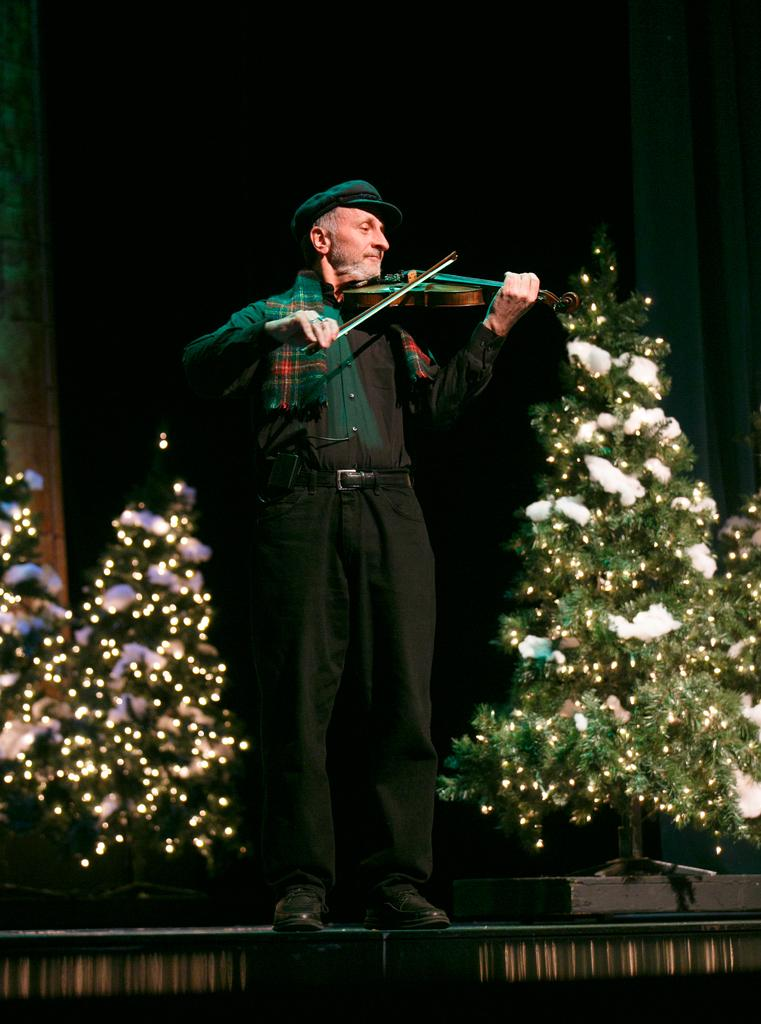What is the man in the image doing? The man is playing a violin. Can you describe the setting of the image? There are trees in the bottom right and bottom left sides of the image. What type of instrument is the man playing? The man is playing a violin. What type of honey can be seen dripping from the violin in the image? There is no honey present in the image; the man is playing a violin without any honey. 